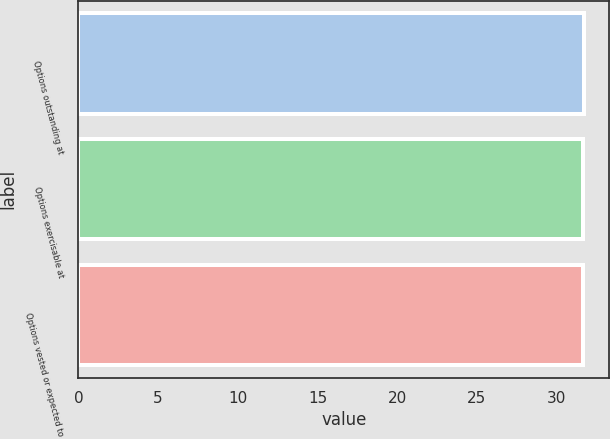Convert chart. <chart><loc_0><loc_0><loc_500><loc_500><bar_chart><fcel>Options outstanding at<fcel>Options exercisable at<fcel>Options vested or expected to<nl><fcel>31.73<fcel>31.63<fcel>31.66<nl></chart> 